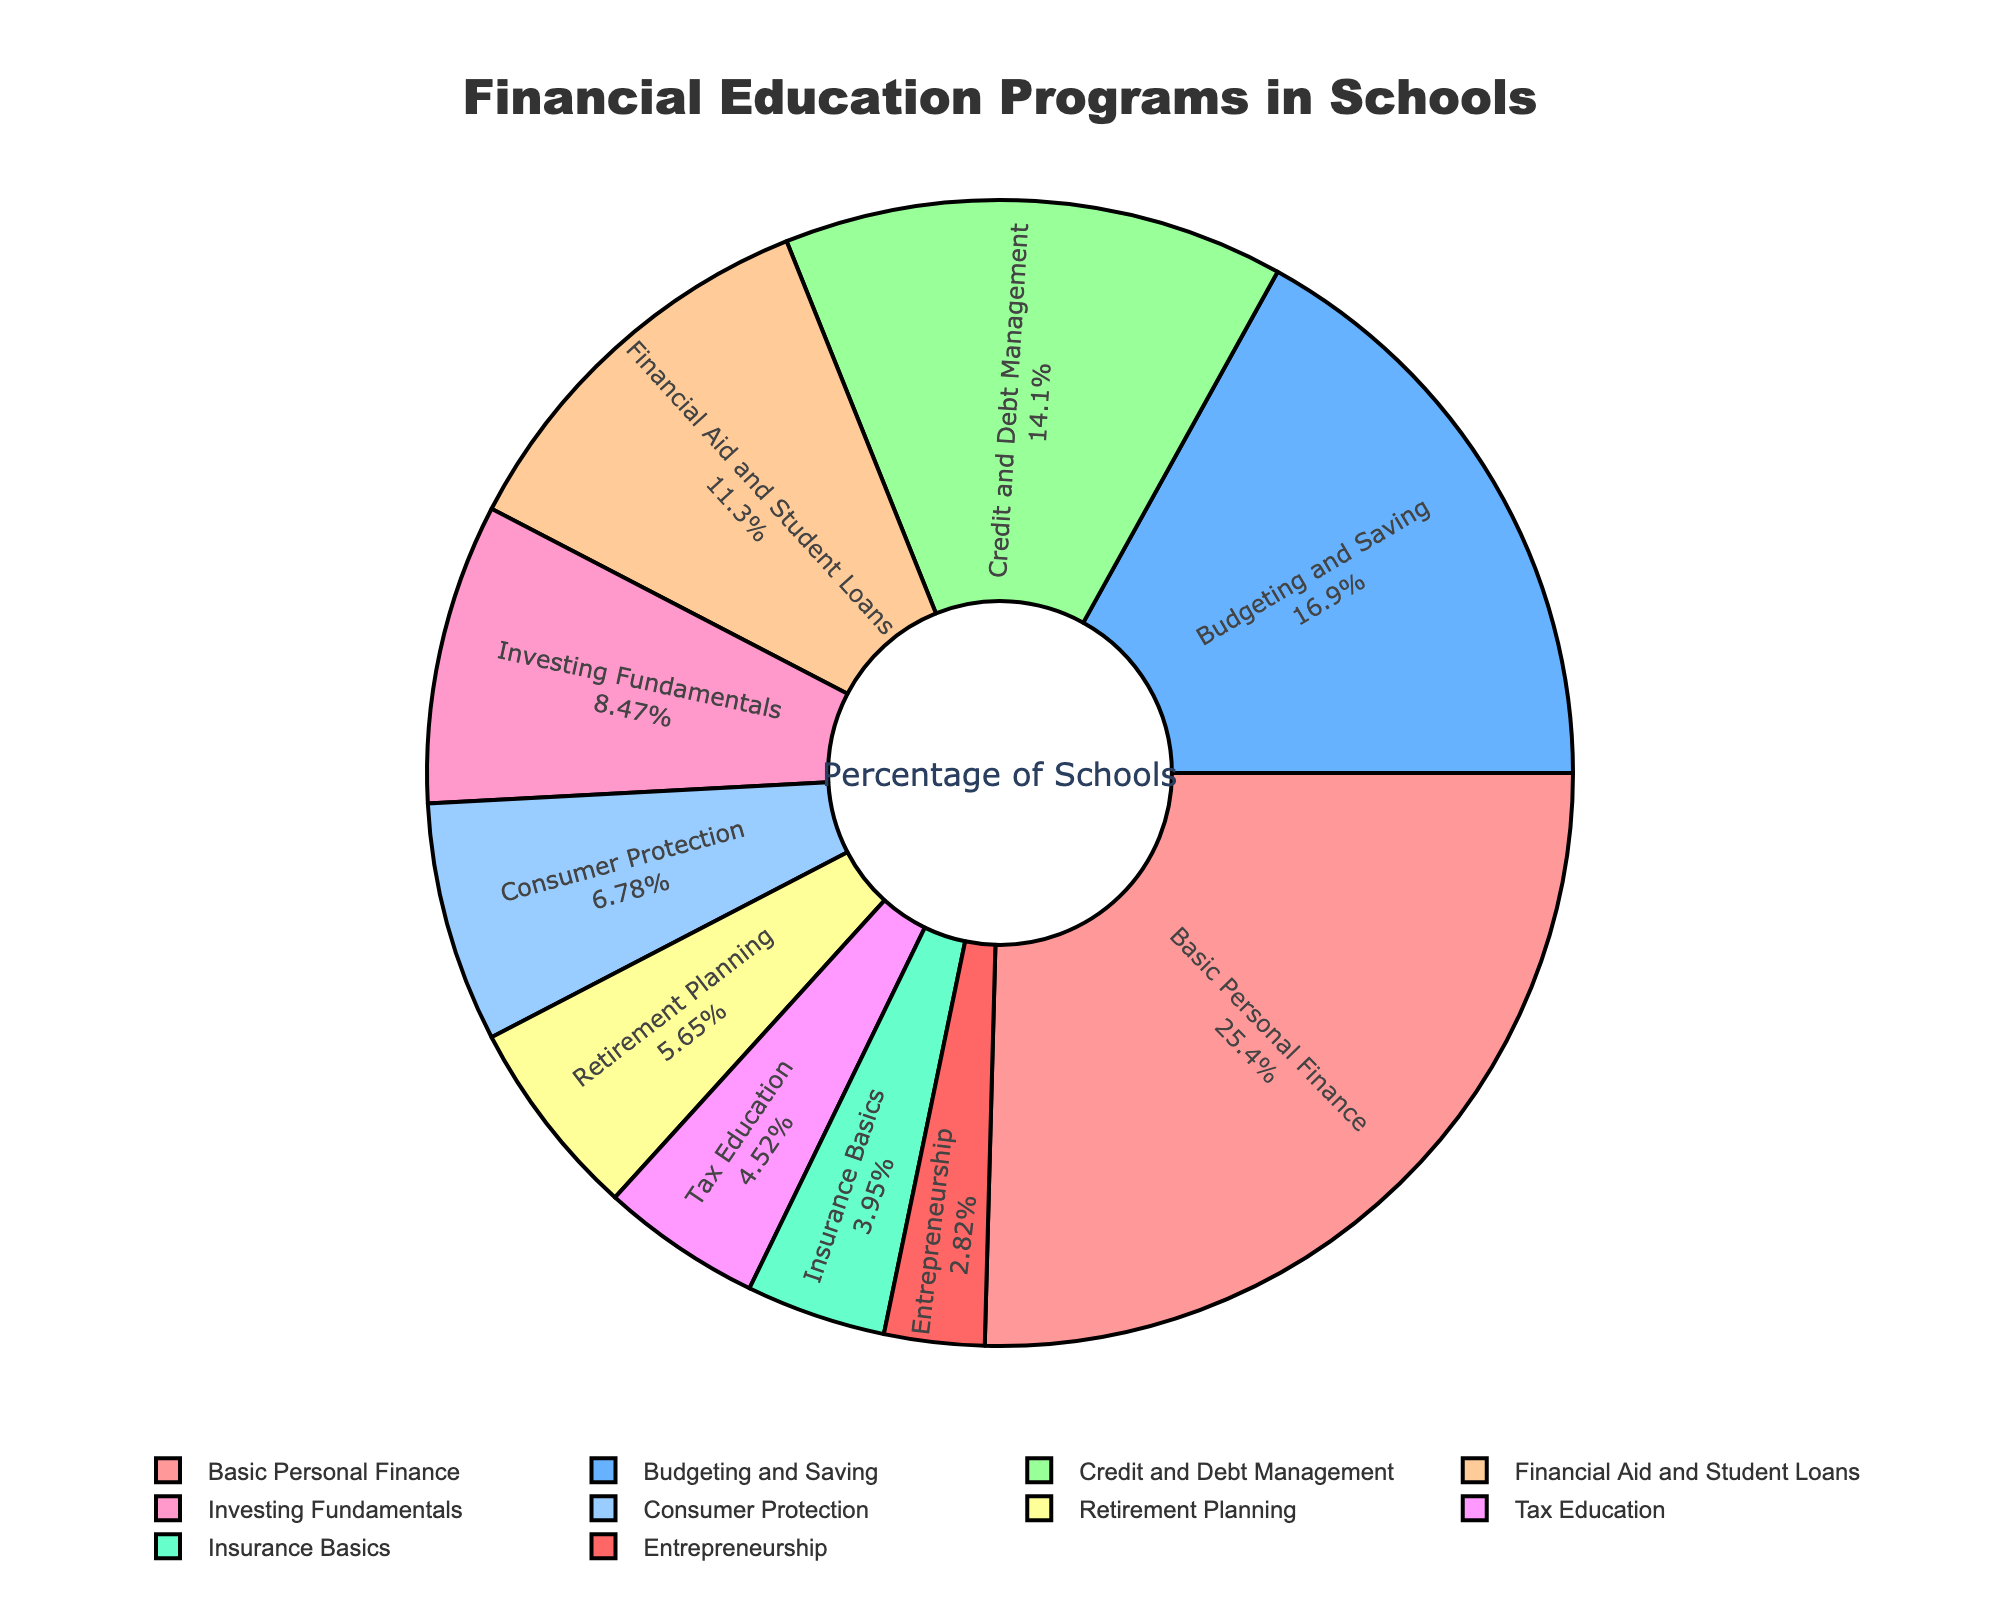What's the largest category of financial education programs offered in the state? The largest category can be determined by observing the section with the highest percentage on the pie chart. It is labeled "Basic Personal Finance" with 45%.
Answer: Basic Personal Finance Which financial education program is offered less frequently: Tax Education or Insurance Basics? The percentages indicate that Tax Education is 8% and Insurance Basics is 7%. Therefore, Insurance Basics is offered less frequently.
Answer: Insurance Basics What is the combined percentage of schools offering both Credit and Debt Management and Financial Aid and Student Loans programs? The percentages for Credit and Debt Management and Financial Aid and Student Loans are 25% and 20%, respectively. Summing them gives 25% + 20% = 45%.
Answer: 45% Which program is offered by fewer schools, Entrepreneurship or Retirement Planning? The percentages are 5% for Entrepreneurship and 10% for Retirement Planning. Thus, Entrepreneurship is offered by fewer schools.
Answer: Entrepreneurship How much higher is the percentage of schools offering Budgeting and Saving compared to those offering Financial Aid and Student Loans? The percentage for Budgeting and Saving is 30%, and Financial Aid and Student Loans is 20%. The difference is 30% - 20% = 10%.
Answer: 10% Rank the top three financial education programs based on their percentage of offerings. The top three can be identified from the highest to lowest percentages: Basic Personal Finance (45%), Budgeting and Saving (30%), and Credit and Debt Management (25%).
Answer: Basic Personal Finance, Budgeting and Saving, Credit and Debt Management Which category occupies the largest visual space in the pie chart? The largest visual space corresponds to the highest percentage, which is Basic Personal Finance at 45%.
Answer: Basic Personal Finance What is the total percentage of schools offering programs related to investments and retirement? The relevant programs are Investing Fundamentals (15%) and Retirement Planning (10%). Adding these gives 15% + 10% = 25%.
Answer: 25% How many percentage points more do schools offer Consumer Protection programs compared to Insurance Basics programs? Consumer Protection is offered by 12% of schools, while Insurance Basics is offered by 7%. The difference is 12% - 7% = 5%.
Answer: 5% What program is represented by the color blue on the pie chart? According to the custom color scale applied, blue (among the listed hex colors) corresponds to the second or third categories on the list. In this case, it is Budgeting and Saving, which is in the second position.
Answer: Budgeting and Saving 